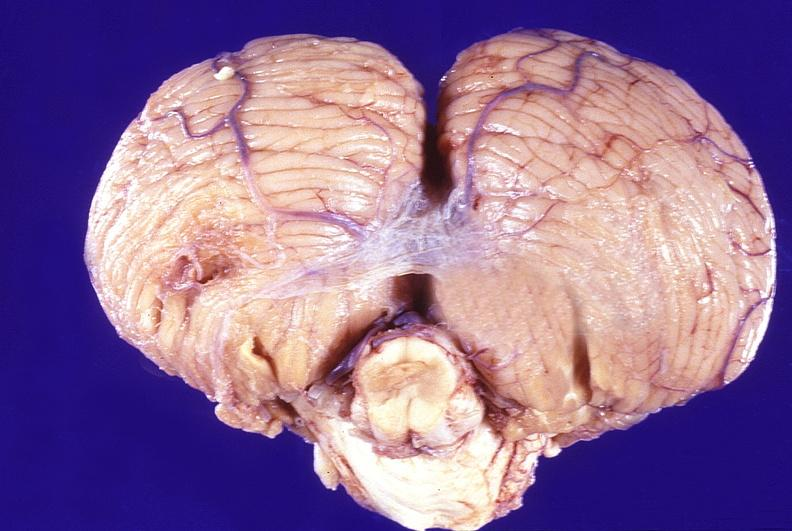does rocky mountain show normal brain?
Answer the question using a single word or phrase. No 